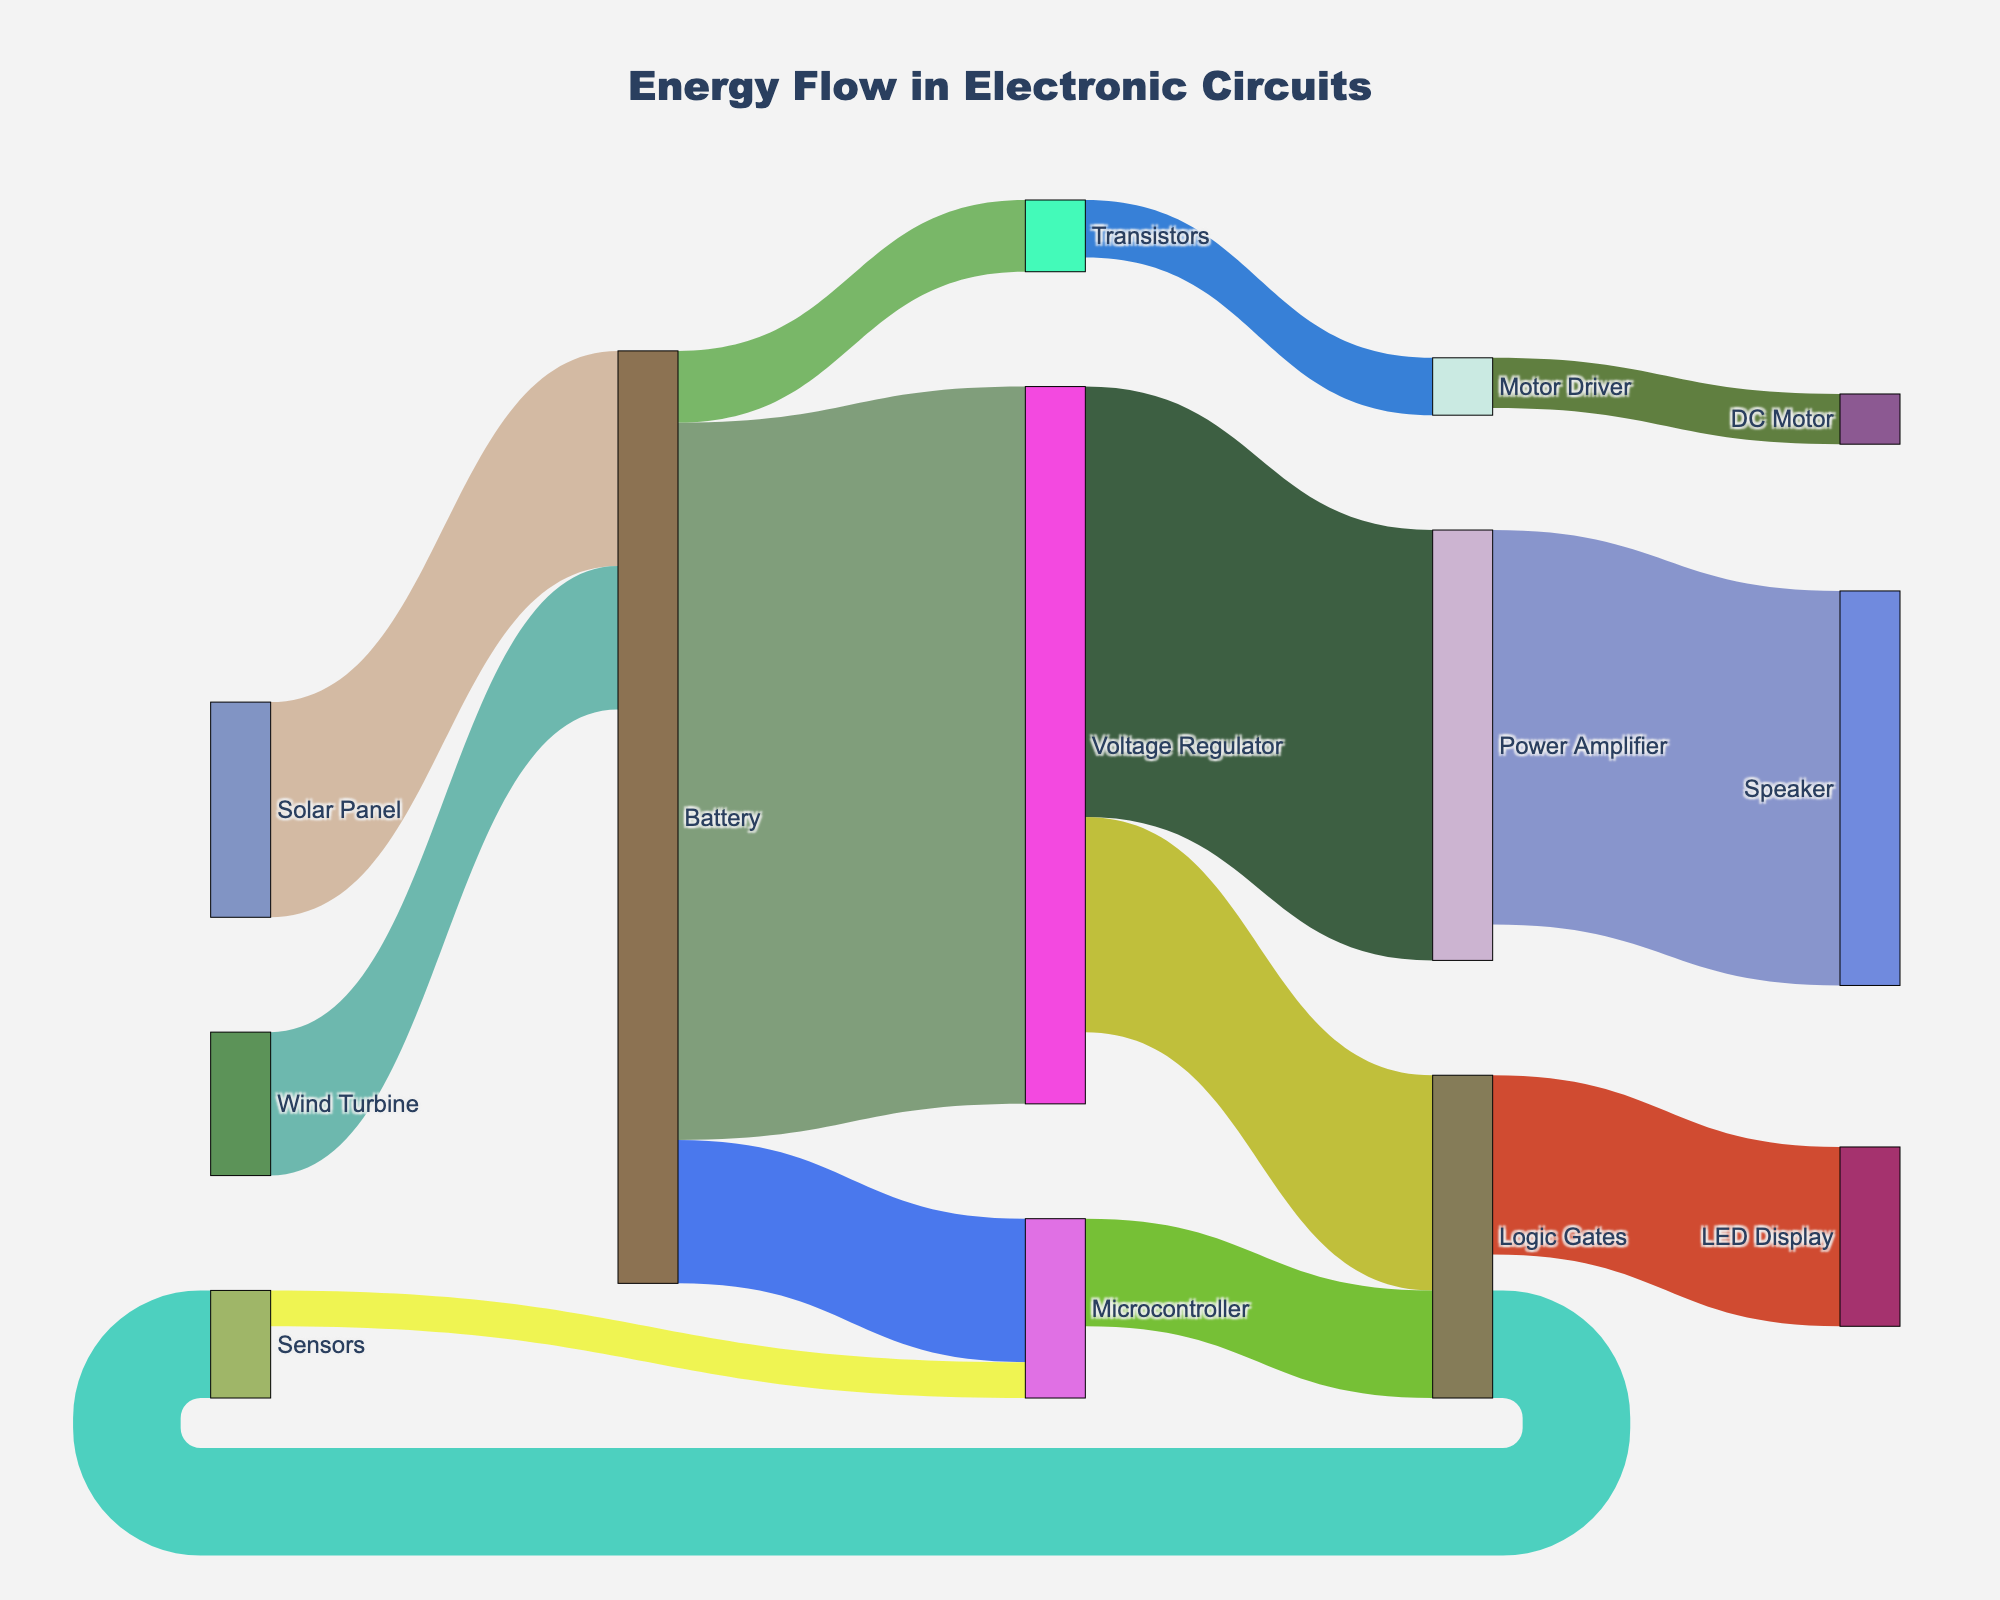What does the title of the figure say? The title of the Sankey Diagram is at the top of the figure and gives an overview of the visualization. The title reads "Energy Flow in Electronic Circuits," which indicates the diagram shows how energy moves through various components in electronic circuits.
Answer: Energy Flow in Electronic Circuits How much energy does the Battery directly supply to the Voltage Regulator? To find this, look at the flow from the Battery to the Voltage Regulator in the diagram. The value associated with this flow is 100 units of energy.
Answer: 100 What components receive energy directly from the Voltage Regulator and how much do they receive? From the diagram, observe the arrows leading out from the Voltage Regulator. The Voltage Regulator supplies energy to the Power Amplifier (60 units) and the Logic Gates (30 units).
Answer: Power Amplifier (60), Logic Gates (30) Which component receives the highest amount of direct energy from any source, and what is that amount? By inspecting the values next to the arrows from all the sources to their targets, identify the highest value. The Power Amplifier receives 60 units from the Voltage Regulator, which is the highest amount of direct energy any component receives.
Answer: Power Amplifier (60) What is the total energy supplied by the Battery, and how do you calculate it? Sum the values of all energy flows originating from the Battery. These are: Voltage Regulator (100), Microcontroller (20), and Transistors (10). The total is 100 + 20 + 10 = 130 units.
Answer: 130 Compare the energy supplied to Logic Gates from different sources. Which source supplies more energy? Energy flows to the Logic Gates from two sources: Voltage Regulator (30 units) and Microcontroller (15 units). The Voltage Regulator supplies more energy to the Logic Gates.
Answer: Voltage Regulator What is the total energy flowing into the Microcontroller from various sources, and how do you calculate it? Add the energy values from all sources that supply the Microcontroller. The Microcontroller receives 20 units directly from the Battery and 5 units from the Sensors. The total is 20 + 5 = 25 units.
Answer: 25 How much energy is ultimately delivered to the DC Motor? Follow the energy flow path to the DC Motor: Battery -> Transistors (10), Transistors -> Motor Driver (8), and Motor Driver -> DC Motor (7). The final amount reaching the DC Motor is 7 units.
Answer: 7 Which renewable energy source, the Solar Panel or Wind Turbine, contributes more energy to the Battery? Examine the flows from the Solar Panel and Wind Turbine. The Solar Panel contributes 30 units, while the Wind Turbine contributes 20 units. The Solar Panel contributes more.
Answer: Solar Panel What is the total energy flowing through the Logic Gates, and how do you calculate it? Add the energy inputs into the Logic Gates and then the energy outputs. Inputs: Voltage Regulator (30) and Microcontroller (15), totaling 45. Outputs: LED Display (25) and Sensors (15), totaling 40. Assuming the diagram is balanced, the total energy flowing through is 45 units.
Answer: 45 